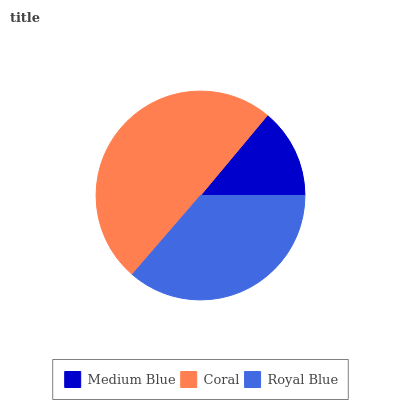Is Medium Blue the minimum?
Answer yes or no. Yes. Is Coral the maximum?
Answer yes or no. Yes. Is Royal Blue the minimum?
Answer yes or no. No. Is Royal Blue the maximum?
Answer yes or no. No. Is Coral greater than Royal Blue?
Answer yes or no. Yes. Is Royal Blue less than Coral?
Answer yes or no. Yes. Is Royal Blue greater than Coral?
Answer yes or no. No. Is Coral less than Royal Blue?
Answer yes or no. No. Is Royal Blue the high median?
Answer yes or no. Yes. Is Royal Blue the low median?
Answer yes or no. Yes. Is Medium Blue the high median?
Answer yes or no. No. Is Medium Blue the low median?
Answer yes or no. No. 